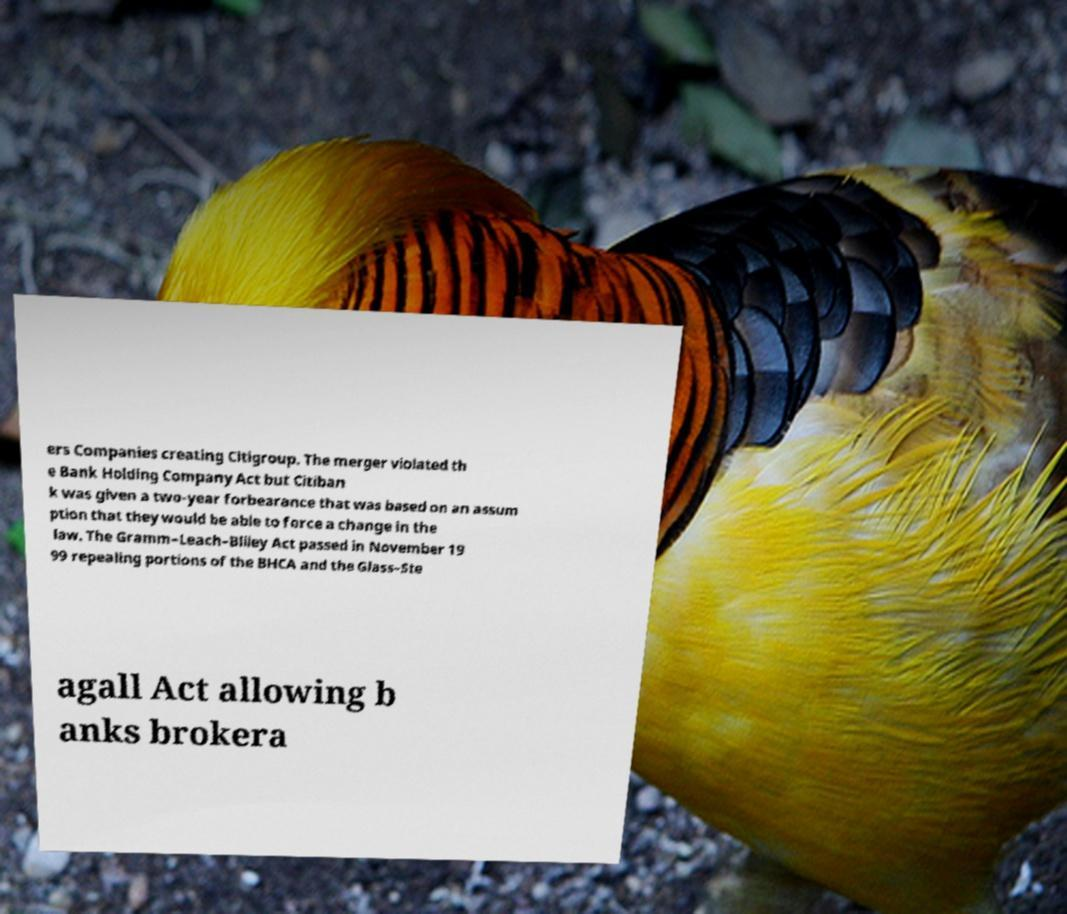There's text embedded in this image that I need extracted. Can you transcribe it verbatim? ers Companies creating Citigroup. The merger violated th e Bank Holding Company Act but Citiban k was given a two-year forbearance that was based on an assum ption that they would be able to force a change in the law. The Gramm–Leach–Bliley Act passed in November 19 99 repealing portions of the BHCA and the Glass–Ste agall Act allowing b anks brokera 